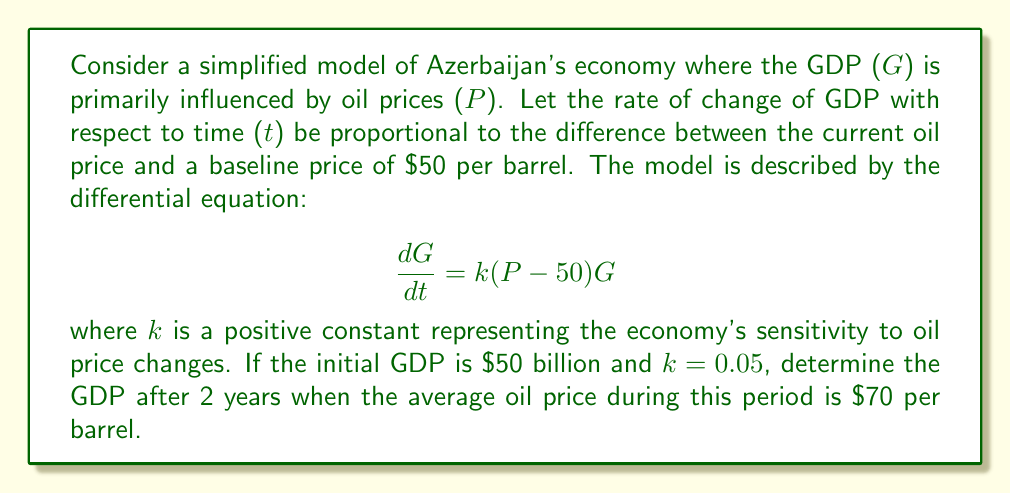Provide a solution to this math problem. To solve this problem, we need to follow these steps:

1) First, we identify the given information:
   - Initial GDP, G(0) = $50 billion
   - k = 0.05
   - P = $70 (average oil price)
   - t = 2 years

2) Our differential equation is:
   $$\frac{dG}{dt} = k(P - 50)G$$

3) Substituting the known values:
   $$\frac{dG}{dt} = 0.05(70 - 50)G = G$$

4) This is a separable differential equation. We can rewrite it as:
   $$\frac{dG}{G} = dt$$

5) Integrating both sides:
   $$\int \frac{dG}{G} = \int dt$$
   $$\ln|G| = t + C$$

6) Solving for G:
   $$G = e^{t + C} = e^C \cdot e^t$$

7) Using the initial condition G(0) = 50 to find C:
   $$50 = e^C \cdot e^0$$
   $$e^C = 50$$

8) Our final solution is:
   $$G = 50e^t$$

9) To find GDP after 2 years, we substitute t = 2:
   $$G(2) = 50e^2 \approx 369.45$$

Therefore, after 2 years, the GDP would be approximately $369.45 billion.
Answer: $369.45 billion 